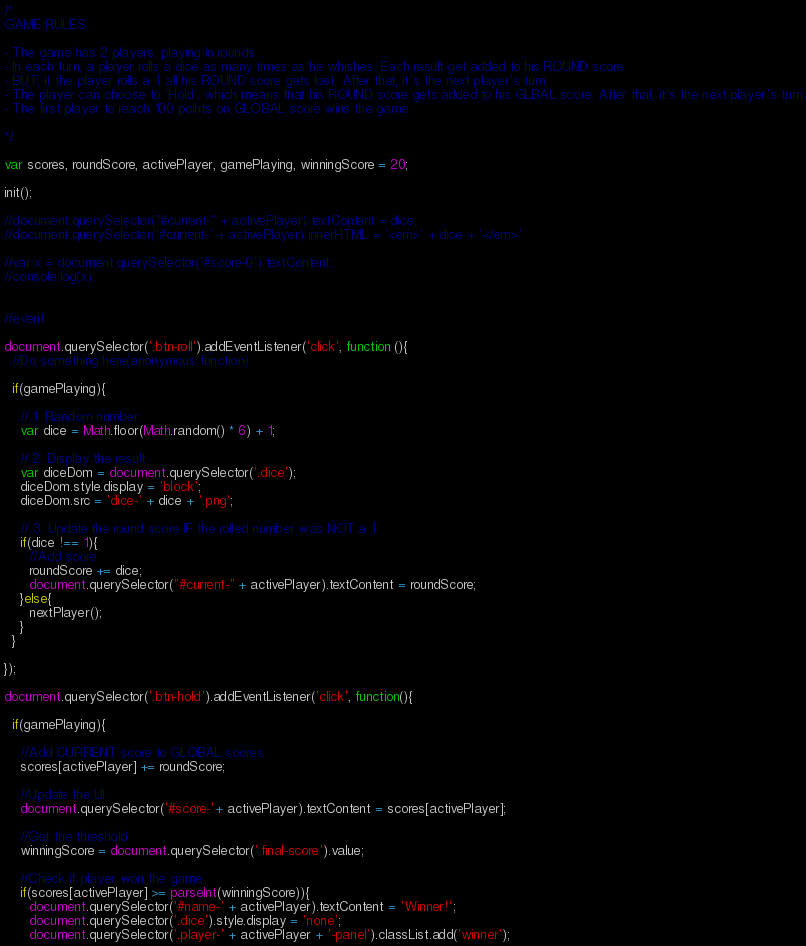<code> <loc_0><loc_0><loc_500><loc_500><_JavaScript_>/*
GAME RULES:

- The game has 2 players, playing in rounds
- In each turn, a player rolls a dice as many times as he whishes. Each result get added to his ROUND score
- BUT, if the player rolls a 1, all his ROUND score gets lost. After that, it's the next player's turn
- The player can choose to 'Hold', which means that his ROUND score gets added to his GLBAL score. After that, it's the next player's turn
- The first player to reach 100 points on GLOBAL score wins the game

*/

var scores, roundScore, activePlayer, gamePlaying, winningScore = 20;

init();

//document.querySelector("#current-" + activePlayer).textContent = dice;
//document.querySelector('#current-' + activePlayer).innerHTML = '<em>' + dice + '</em>'

//var x = document.querySelector('#score-0').textContent;
//console.log(x);


//event

document.querySelector('.btn-roll').addEventListener('click', function (){
  //Do something here(anonymous function)

  if(gamePlaying){

    // 1. Random number;
    var dice = Math.floor(Math.random() * 6) + 1;

    // 2. Display the result
    var diceDom = document.querySelector('.dice');
    diceDom.style.display = 'block';
    diceDom.src = 'dice-' + dice + '.png';

    // 3. Update the round score IF the rolled number was NOT a 1
    if(dice !== 1){
      //Add score
      roundScore += dice;
      document.querySelector("#current-" + activePlayer).textContent = roundScore;
    }else{
      nextPlayer();
    }
  }

});

document.querySelector('.btn-hold').addEventListener('click', function(){

  if(gamePlaying){

    //Add CURRENT score to GLOBAL scores
    scores[activePlayer] += roundScore;

    //Update the UI
    document.querySelector('#score-'+ activePlayer).textContent = scores[activePlayer];

    //Get the threshold
    winningScore = document.querySelector('.final-score').value;

    //Check if player won the game
    if(scores[activePlayer] >= parseInt(winningScore)){
      document.querySelector('#name-' + activePlayer).textContent = 'Winner!';
      document.querySelector('.dice').style.display = 'none';
      document.querySelector('.player-' + activePlayer + '-panel').classList.add('winner');</code> 